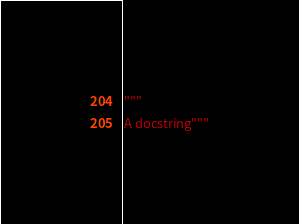Convert code to text. <code><loc_0><loc_0><loc_500><loc_500><_Python_>"""
A docstring"""
</code> 